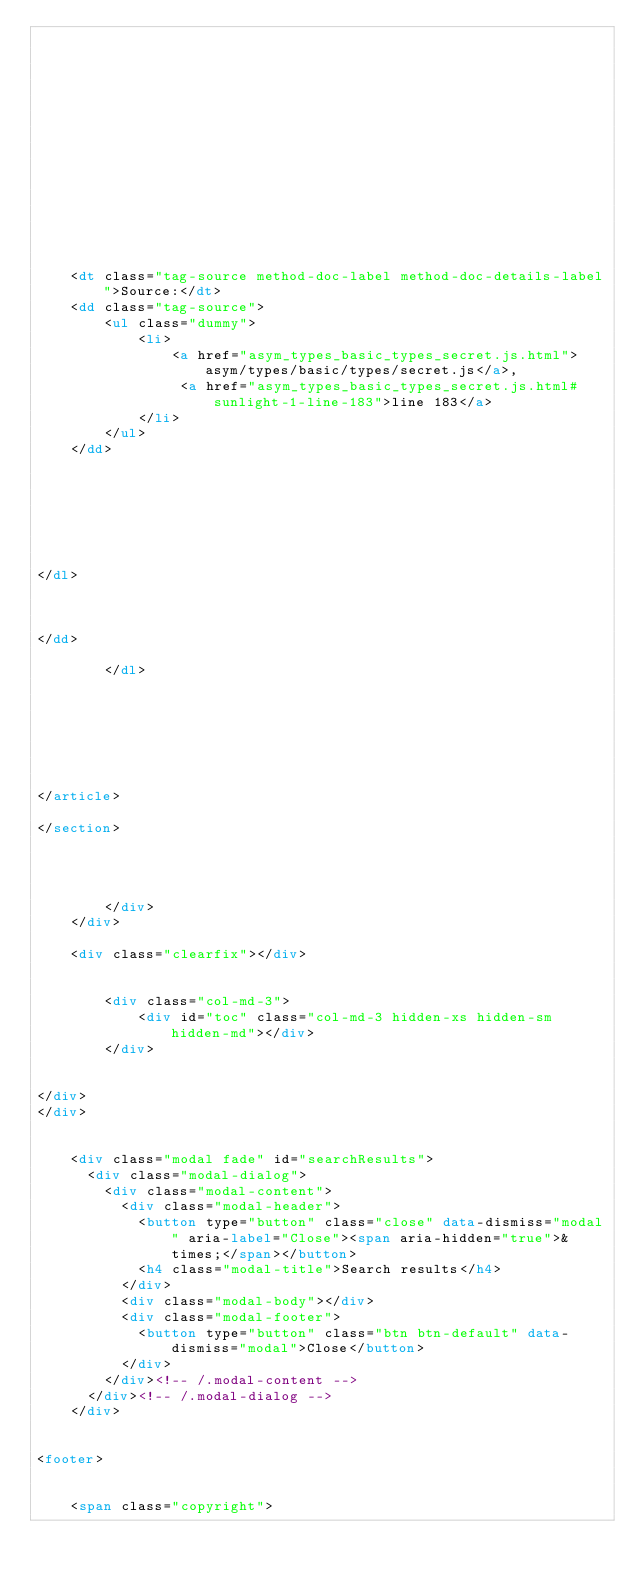<code> <loc_0><loc_0><loc_500><loc_500><_HTML_>    

	

	

	

	

	



	
	<dt class="tag-source method-doc-label method-doc-details-label">Source:</dt>
	<dd class="tag-source">
		<ul class="dummy">
			<li>
				<a href="asym_types_basic_types_secret.js.html">asym/types/basic/types/secret.js</a>,
				 <a href="asym_types_basic_types_secret.js.html#sunlight-1-line-183">line 183</a>
			</li>
		</ul>
	</dd>
	

	

	

	
</dl>


    
</dd>

        </dl>
    

    

    

    
</article>

</section>




		</div>
	</div>

	<div class="clearfix"></div>

	
		<div class="col-md-3">
			<div id="toc" class="col-md-3 hidden-xs hidden-sm hidden-md"></div>
		</div>
	

</div>
</div>


    <div class="modal fade" id="searchResults">
      <div class="modal-dialog">
        <div class="modal-content">
          <div class="modal-header">
            <button type="button" class="close" data-dismiss="modal" aria-label="Close"><span aria-hidden="true">&times;</span></button>
            <h4 class="modal-title">Search results</h4>
          </div>
          <div class="modal-body"></div>
          <div class="modal-footer">
            <button type="button" class="btn btn-default" data-dismiss="modal">Close</button>
          </div>
        </div><!-- /.modal-content -->
      </div><!-- /.modal-dialog -->
    </div>


<footer>


	<span class="copyright"></code> 